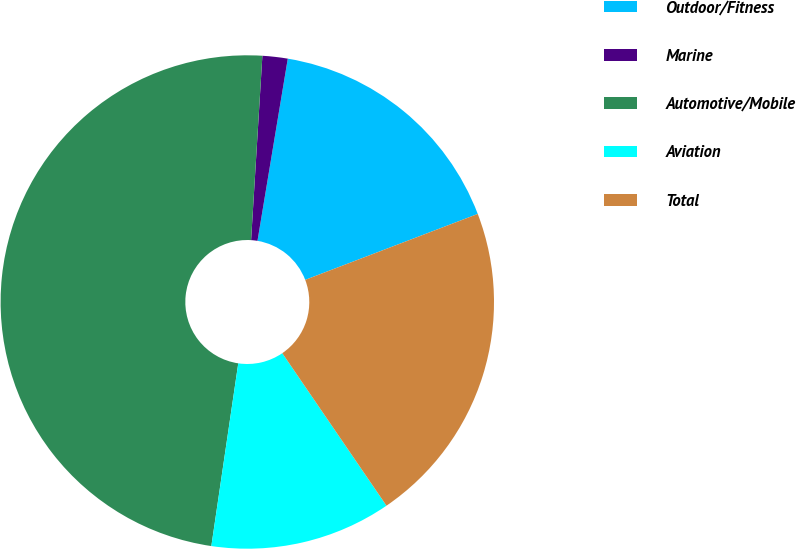<chart> <loc_0><loc_0><loc_500><loc_500><pie_chart><fcel>Outdoor/Fitness<fcel>Marine<fcel>Automotive/Mobile<fcel>Aviation<fcel>Total<nl><fcel>16.57%<fcel>1.65%<fcel>48.65%<fcel>11.87%<fcel>21.27%<nl></chart> 